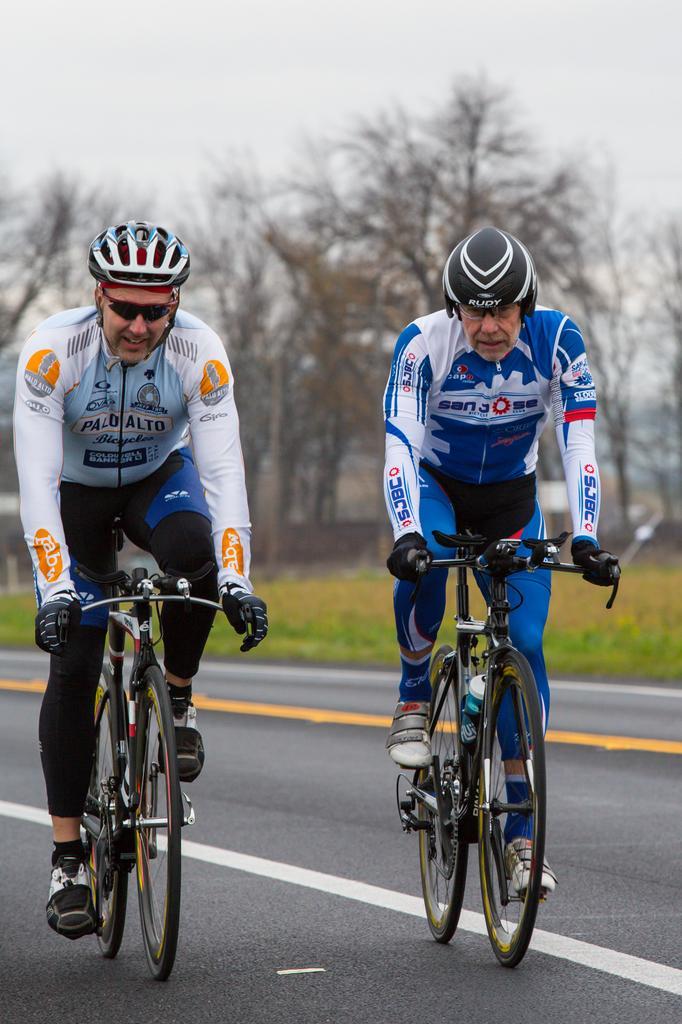How would you summarize this image in a sentence or two? In this picture I can see there are two people riding the bicycles and they are wearing helmets and there is grass on the right side, there are trees in the backdrop and the sky is clear. 